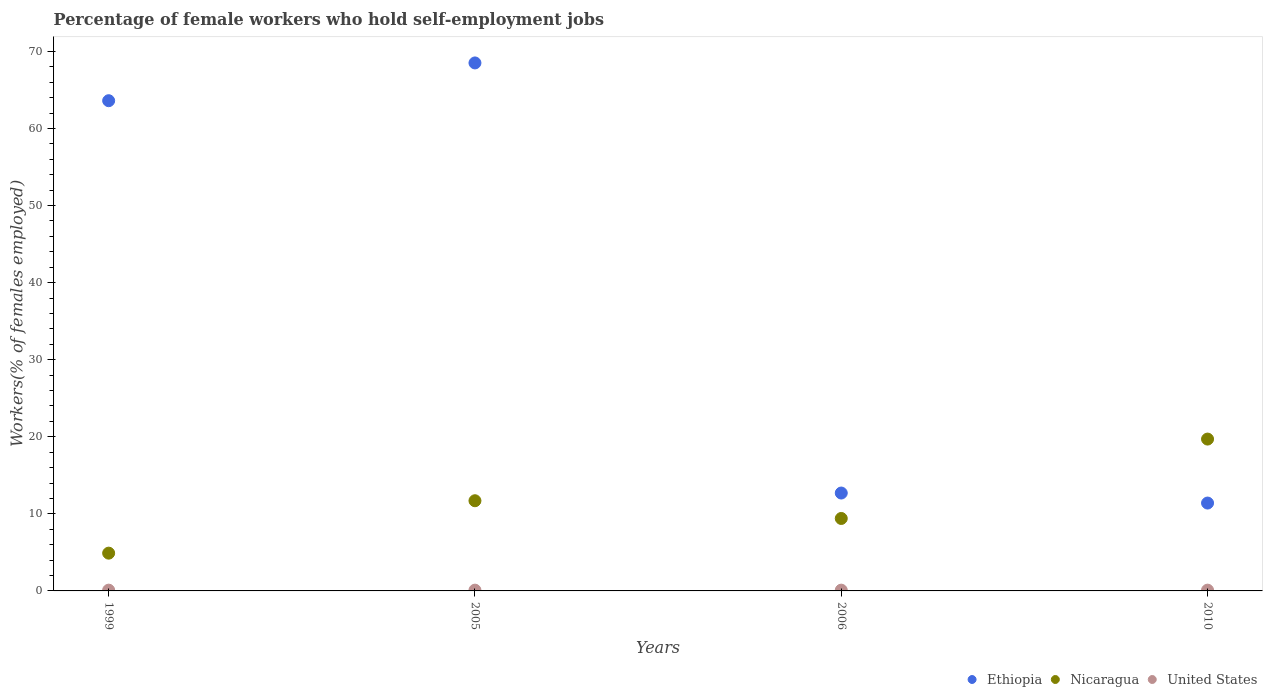What is the percentage of self-employed female workers in Nicaragua in 2010?
Your answer should be compact. 19.7. Across all years, what is the maximum percentage of self-employed female workers in Nicaragua?
Provide a short and direct response. 19.7. Across all years, what is the minimum percentage of self-employed female workers in United States?
Provide a short and direct response. 0.1. In which year was the percentage of self-employed female workers in United States maximum?
Provide a short and direct response. 1999. In which year was the percentage of self-employed female workers in United States minimum?
Offer a very short reply. 1999. What is the total percentage of self-employed female workers in United States in the graph?
Provide a succinct answer. 0.4. What is the difference between the percentage of self-employed female workers in Nicaragua in 1999 and that in 2005?
Offer a terse response. -6.8. What is the difference between the percentage of self-employed female workers in United States in 2005 and the percentage of self-employed female workers in Ethiopia in 2010?
Offer a terse response. -11.3. What is the average percentage of self-employed female workers in Ethiopia per year?
Make the answer very short. 39.05. In the year 1999, what is the difference between the percentage of self-employed female workers in Ethiopia and percentage of self-employed female workers in United States?
Your answer should be compact. 63.5. What is the ratio of the percentage of self-employed female workers in Nicaragua in 2005 to that in 2006?
Your answer should be compact. 1.24. Is the difference between the percentage of self-employed female workers in Ethiopia in 2005 and 2010 greater than the difference between the percentage of self-employed female workers in United States in 2005 and 2010?
Your answer should be very brief. Yes. What is the difference between the highest and the second highest percentage of self-employed female workers in United States?
Offer a terse response. 0. What is the difference between the highest and the lowest percentage of self-employed female workers in United States?
Your answer should be compact. 0. In how many years, is the percentage of self-employed female workers in Ethiopia greater than the average percentage of self-employed female workers in Ethiopia taken over all years?
Offer a very short reply. 2. Is the sum of the percentage of self-employed female workers in Ethiopia in 1999 and 2006 greater than the maximum percentage of self-employed female workers in Nicaragua across all years?
Your answer should be compact. Yes. Does the percentage of self-employed female workers in Nicaragua monotonically increase over the years?
Offer a very short reply. No. How many dotlines are there?
Give a very brief answer. 3. What is the difference between two consecutive major ticks on the Y-axis?
Give a very brief answer. 10. Are the values on the major ticks of Y-axis written in scientific E-notation?
Make the answer very short. No. Does the graph contain grids?
Keep it short and to the point. No. Where does the legend appear in the graph?
Your answer should be very brief. Bottom right. What is the title of the graph?
Provide a succinct answer. Percentage of female workers who hold self-employment jobs. Does "Croatia" appear as one of the legend labels in the graph?
Offer a terse response. No. What is the label or title of the X-axis?
Ensure brevity in your answer.  Years. What is the label or title of the Y-axis?
Ensure brevity in your answer.  Workers(% of females employed). What is the Workers(% of females employed) in Ethiopia in 1999?
Provide a succinct answer. 63.6. What is the Workers(% of females employed) in Nicaragua in 1999?
Your response must be concise. 4.9. What is the Workers(% of females employed) of United States in 1999?
Offer a terse response. 0.1. What is the Workers(% of females employed) in Ethiopia in 2005?
Your answer should be very brief. 68.5. What is the Workers(% of females employed) of Nicaragua in 2005?
Provide a succinct answer. 11.7. What is the Workers(% of females employed) of United States in 2005?
Offer a very short reply. 0.1. What is the Workers(% of females employed) of Ethiopia in 2006?
Give a very brief answer. 12.7. What is the Workers(% of females employed) of Nicaragua in 2006?
Ensure brevity in your answer.  9.4. What is the Workers(% of females employed) of United States in 2006?
Your answer should be compact. 0.1. What is the Workers(% of females employed) in Ethiopia in 2010?
Ensure brevity in your answer.  11.4. What is the Workers(% of females employed) of Nicaragua in 2010?
Ensure brevity in your answer.  19.7. What is the Workers(% of females employed) of United States in 2010?
Your answer should be compact. 0.1. Across all years, what is the maximum Workers(% of females employed) in Ethiopia?
Keep it short and to the point. 68.5. Across all years, what is the maximum Workers(% of females employed) of Nicaragua?
Your response must be concise. 19.7. Across all years, what is the maximum Workers(% of females employed) of United States?
Keep it short and to the point. 0.1. Across all years, what is the minimum Workers(% of females employed) in Ethiopia?
Offer a very short reply. 11.4. Across all years, what is the minimum Workers(% of females employed) in Nicaragua?
Ensure brevity in your answer.  4.9. Across all years, what is the minimum Workers(% of females employed) of United States?
Offer a very short reply. 0.1. What is the total Workers(% of females employed) in Ethiopia in the graph?
Provide a short and direct response. 156.2. What is the total Workers(% of females employed) in Nicaragua in the graph?
Your answer should be compact. 45.7. What is the difference between the Workers(% of females employed) in Nicaragua in 1999 and that in 2005?
Make the answer very short. -6.8. What is the difference between the Workers(% of females employed) of United States in 1999 and that in 2005?
Keep it short and to the point. 0. What is the difference between the Workers(% of females employed) in Ethiopia in 1999 and that in 2006?
Give a very brief answer. 50.9. What is the difference between the Workers(% of females employed) of Nicaragua in 1999 and that in 2006?
Keep it short and to the point. -4.5. What is the difference between the Workers(% of females employed) in Ethiopia in 1999 and that in 2010?
Ensure brevity in your answer.  52.2. What is the difference between the Workers(% of females employed) in Nicaragua in 1999 and that in 2010?
Offer a terse response. -14.8. What is the difference between the Workers(% of females employed) in Ethiopia in 2005 and that in 2006?
Your answer should be compact. 55.8. What is the difference between the Workers(% of females employed) in Ethiopia in 2005 and that in 2010?
Ensure brevity in your answer.  57.1. What is the difference between the Workers(% of females employed) of Ethiopia in 2006 and that in 2010?
Your answer should be very brief. 1.3. What is the difference between the Workers(% of females employed) of Ethiopia in 1999 and the Workers(% of females employed) of Nicaragua in 2005?
Offer a terse response. 51.9. What is the difference between the Workers(% of females employed) of Ethiopia in 1999 and the Workers(% of females employed) of United States in 2005?
Your response must be concise. 63.5. What is the difference between the Workers(% of females employed) in Nicaragua in 1999 and the Workers(% of females employed) in United States in 2005?
Your response must be concise. 4.8. What is the difference between the Workers(% of females employed) in Ethiopia in 1999 and the Workers(% of females employed) in Nicaragua in 2006?
Provide a short and direct response. 54.2. What is the difference between the Workers(% of females employed) in Ethiopia in 1999 and the Workers(% of females employed) in United States in 2006?
Make the answer very short. 63.5. What is the difference between the Workers(% of females employed) in Ethiopia in 1999 and the Workers(% of females employed) in Nicaragua in 2010?
Keep it short and to the point. 43.9. What is the difference between the Workers(% of females employed) in Ethiopia in 1999 and the Workers(% of females employed) in United States in 2010?
Your response must be concise. 63.5. What is the difference between the Workers(% of females employed) of Ethiopia in 2005 and the Workers(% of females employed) of Nicaragua in 2006?
Your response must be concise. 59.1. What is the difference between the Workers(% of females employed) in Ethiopia in 2005 and the Workers(% of females employed) in United States in 2006?
Provide a succinct answer. 68.4. What is the difference between the Workers(% of females employed) in Nicaragua in 2005 and the Workers(% of females employed) in United States in 2006?
Make the answer very short. 11.6. What is the difference between the Workers(% of females employed) in Ethiopia in 2005 and the Workers(% of females employed) in Nicaragua in 2010?
Keep it short and to the point. 48.8. What is the difference between the Workers(% of females employed) in Ethiopia in 2005 and the Workers(% of females employed) in United States in 2010?
Offer a very short reply. 68.4. What is the difference between the Workers(% of females employed) in Nicaragua in 2005 and the Workers(% of females employed) in United States in 2010?
Make the answer very short. 11.6. What is the difference between the Workers(% of females employed) in Ethiopia in 2006 and the Workers(% of females employed) in Nicaragua in 2010?
Ensure brevity in your answer.  -7. What is the difference between the Workers(% of females employed) of Ethiopia in 2006 and the Workers(% of females employed) of United States in 2010?
Offer a very short reply. 12.6. What is the average Workers(% of females employed) of Ethiopia per year?
Offer a terse response. 39.05. What is the average Workers(% of females employed) of Nicaragua per year?
Your response must be concise. 11.43. What is the average Workers(% of females employed) in United States per year?
Your answer should be very brief. 0.1. In the year 1999, what is the difference between the Workers(% of females employed) in Ethiopia and Workers(% of females employed) in Nicaragua?
Offer a terse response. 58.7. In the year 1999, what is the difference between the Workers(% of females employed) in Ethiopia and Workers(% of females employed) in United States?
Your answer should be very brief. 63.5. In the year 2005, what is the difference between the Workers(% of females employed) of Ethiopia and Workers(% of females employed) of Nicaragua?
Offer a terse response. 56.8. In the year 2005, what is the difference between the Workers(% of females employed) in Ethiopia and Workers(% of females employed) in United States?
Provide a short and direct response. 68.4. In the year 2006, what is the difference between the Workers(% of females employed) of Nicaragua and Workers(% of females employed) of United States?
Keep it short and to the point. 9.3. In the year 2010, what is the difference between the Workers(% of females employed) of Ethiopia and Workers(% of females employed) of Nicaragua?
Provide a succinct answer. -8.3. In the year 2010, what is the difference between the Workers(% of females employed) in Nicaragua and Workers(% of females employed) in United States?
Your answer should be compact. 19.6. What is the ratio of the Workers(% of females employed) in Ethiopia in 1999 to that in 2005?
Ensure brevity in your answer.  0.93. What is the ratio of the Workers(% of females employed) of Nicaragua in 1999 to that in 2005?
Offer a terse response. 0.42. What is the ratio of the Workers(% of females employed) in Ethiopia in 1999 to that in 2006?
Give a very brief answer. 5.01. What is the ratio of the Workers(% of females employed) of Nicaragua in 1999 to that in 2006?
Make the answer very short. 0.52. What is the ratio of the Workers(% of females employed) in Ethiopia in 1999 to that in 2010?
Give a very brief answer. 5.58. What is the ratio of the Workers(% of females employed) of Nicaragua in 1999 to that in 2010?
Your answer should be very brief. 0.25. What is the ratio of the Workers(% of females employed) of Ethiopia in 2005 to that in 2006?
Make the answer very short. 5.39. What is the ratio of the Workers(% of females employed) in Nicaragua in 2005 to that in 2006?
Provide a succinct answer. 1.24. What is the ratio of the Workers(% of females employed) in Ethiopia in 2005 to that in 2010?
Your answer should be very brief. 6.01. What is the ratio of the Workers(% of females employed) in Nicaragua in 2005 to that in 2010?
Your answer should be compact. 0.59. What is the ratio of the Workers(% of females employed) of Ethiopia in 2006 to that in 2010?
Your answer should be compact. 1.11. What is the ratio of the Workers(% of females employed) in Nicaragua in 2006 to that in 2010?
Make the answer very short. 0.48. What is the difference between the highest and the second highest Workers(% of females employed) in United States?
Give a very brief answer. 0. What is the difference between the highest and the lowest Workers(% of females employed) of Ethiopia?
Give a very brief answer. 57.1. What is the difference between the highest and the lowest Workers(% of females employed) in Nicaragua?
Give a very brief answer. 14.8. 